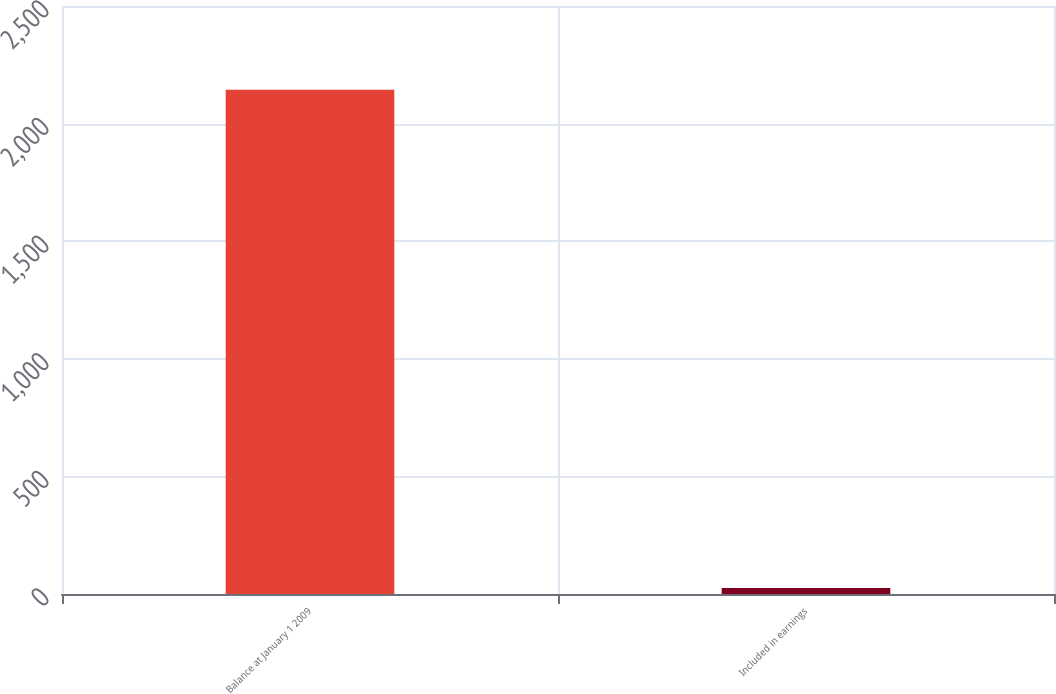<chart> <loc_0><loc_0><loc_500><loc_500><bar_chart><fcel>Balance at January 1 2009<fcel>Included in earnings<nl><fcel>2144<fcel>26<nl></chart> 